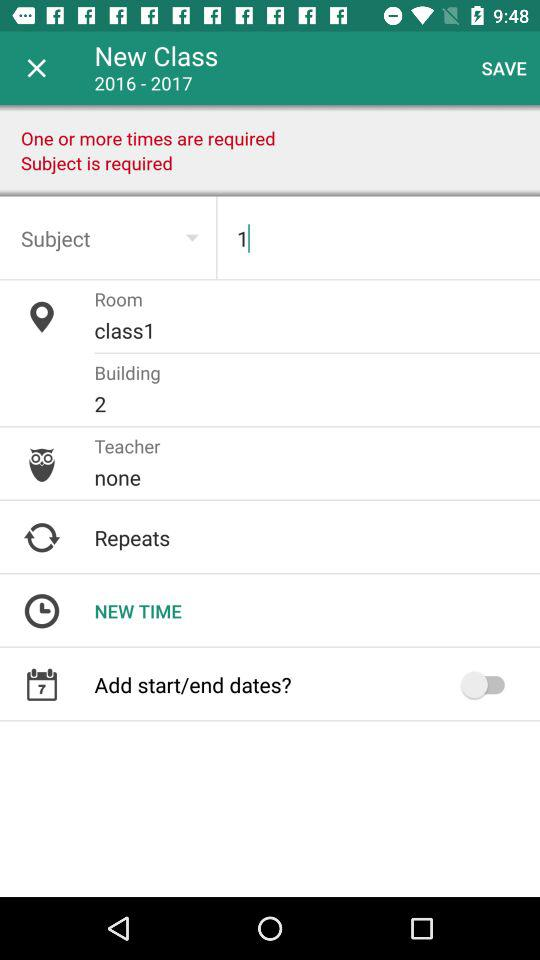What is the session of the new class? The session of the new class is 2016 – 2017. 